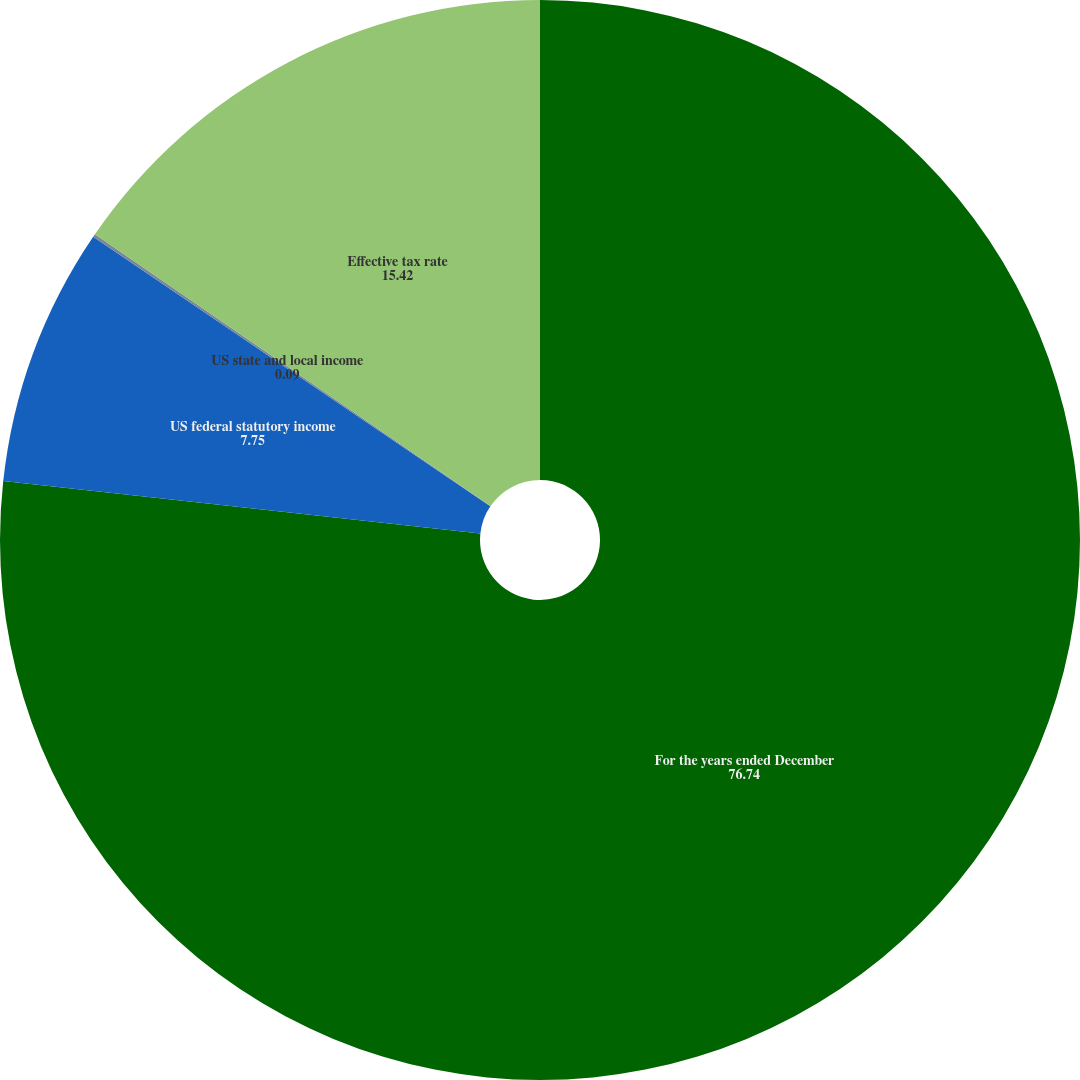Convert chart to OTSL. <chart><loc_0><loc_0><loc_500><loc_500><pie_chart><fcel>For the years ended December<fcel>US federal statutory income<fcel>US state and local income<fcel>Effective tax rate<nl><fcel>76.74%<fcel>7.75%<fcel>0.09%<fcel>15.42%<nl></chart> 